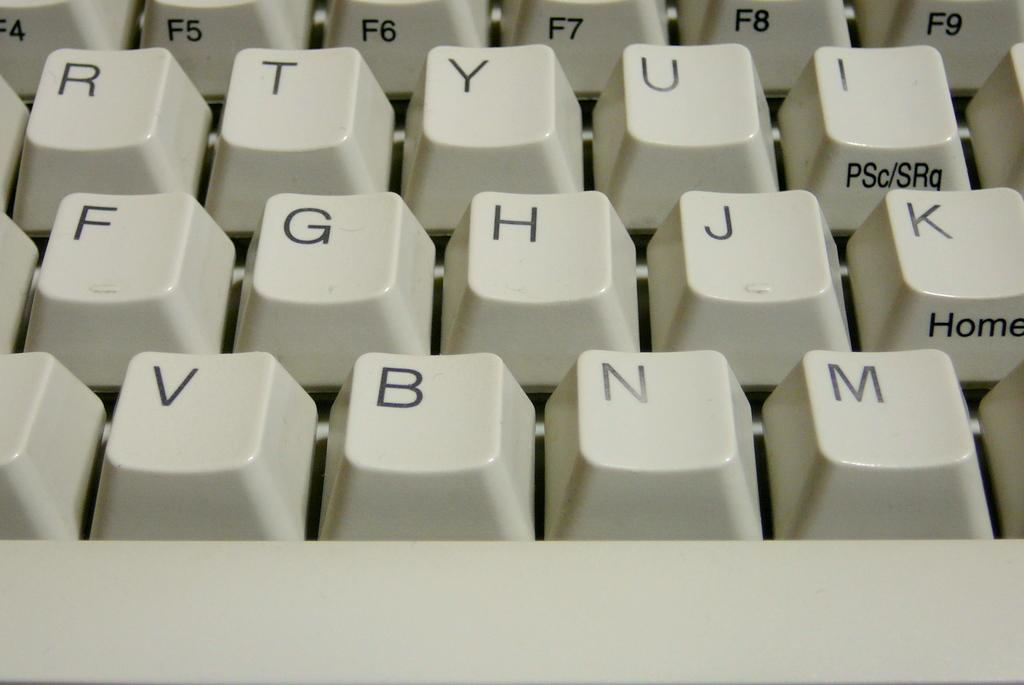<image>
Give a short and clear explanation of the subsequent image. A close up picture of a white keyboard that says home on one button 